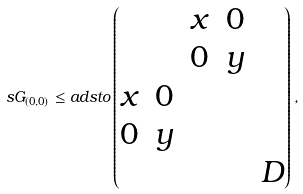<formula> <loc_0><loc_0><loc_500><loc_500>\ s G _ { ( 0 , 0 ) } \leq a d s t o \begin{pmatrix} & & x & 0 \\ & & 0 & y \\ x & 0 \\ 0 & y \\ & & & & D \end{pmatrix} ,</formula> 